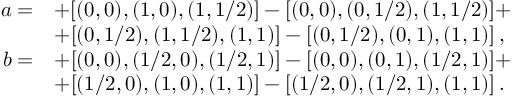Convert formula to latex. <formula><loc_0><loc_0><loc_500><loc_500>\begin{array} { r l } { a = } & { + [ ( 0 , 0 ) , ( 1 , 0 ) , ( 1 , 1 / 2 ) ] - [ ( 0 , 0 ) , ( 0 , 1 / 2 ) , ( 1 , 1 / 2 ) ] + } \\ & { + [ ( 0 , 1 / 2 ) , ( 1 , 1 / 2 ) , ( 1 , 1 ) ] - [ ( 0 , 1 / 2 ) , ( 0 , 1 ) , ( 1 , 1 ) ] \, , } \\ { b = } & { + [ ( 0 , 0 ) , ( 1 / 2 , 0 ) , ( 1 / 2 , 1 ) ] - [ ( 0 , 0 ) , ( 0 , 1 ) , ( 1 / 2 , 1 ) ] + } \\ & { + [ ( 1 / 2 , 0 ) , ( 1 , 0 ) , ( 1 , 1 ) ] - [ ( 1 / 2 , 0 ) , ( 1 / 2 , 1 ) , ( 1 , 1 ) ] \, . } \end{array}</formula> 